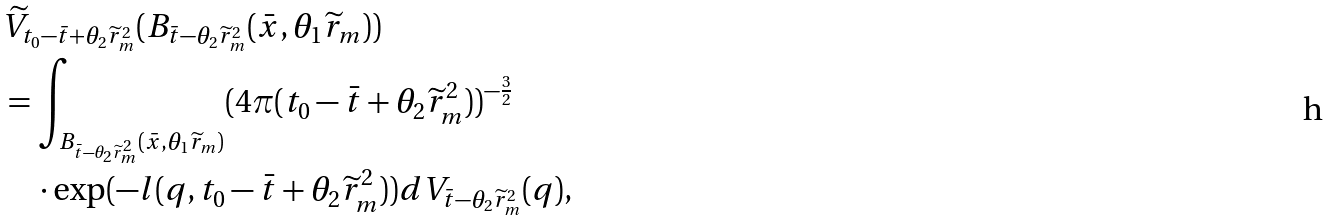Convert formula to latex. <formula><loc_0><loc_0><loc_500><loc_500>& \widetilde { V } _ { t _ { 0 } - \bar { t } + \theta _ { 2 } \widetilde { r } ^ { 2 } _ { m } } ( B _ { \bar { t } - \theta _ { 2 } \widetilde { r } ^ { 2 } _ { m } } ( \bar { x } , \theta _ { 1 } \widetilde { r } _ { m } ) ) \\ & = \int _ { B _ { \bar { t } - \theta _ { 2 } \widetilde { r } ^ { 2 } _ { m } } ( \bar { x } , \theta _ { 1 } \widetilde { r } _ { m } ) } ( 4 \pi ( t _ { 0 } - \bar { t } + \theta _ { 2 } \widetilde { r } ^ { 2 } _ { m } ) ) ^ { - \frac { 3 } { 2 } } \\ & \quad \cdot \exp ( - l ( q , t _ { 0 } - \bar { t } + \theta _ { 2 } \widetilde { r } ^ { 2 } _ { m } ) ) d V _ { \bar { t } - \theta _ { 2 } \widetilde { r } ^ { 2 } _ { m } } ( q ) ,</formula> 